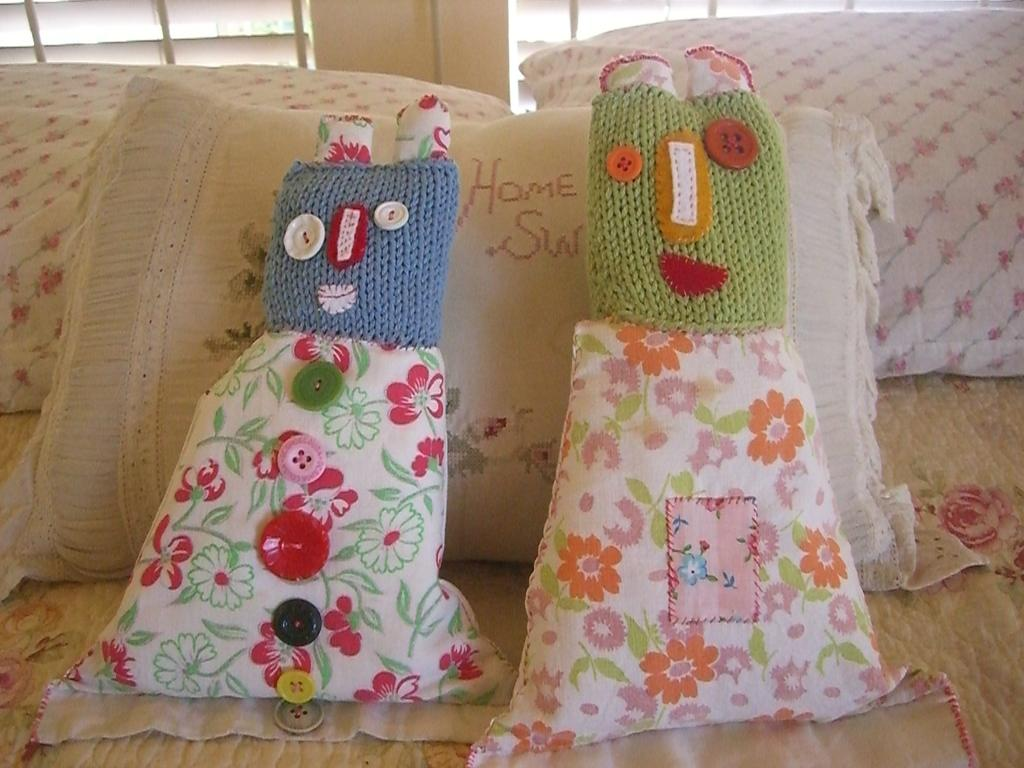What type of furniture is present in the image? There is a couch in the image. What is placed on the couch? There are cushions on the couch. Can you describe any text or symbols visible in the image? Yes, there is writing visible in the image. Is there a skateboard being used as a gun in the image? No, there is no skateboard or gun present in the image. 